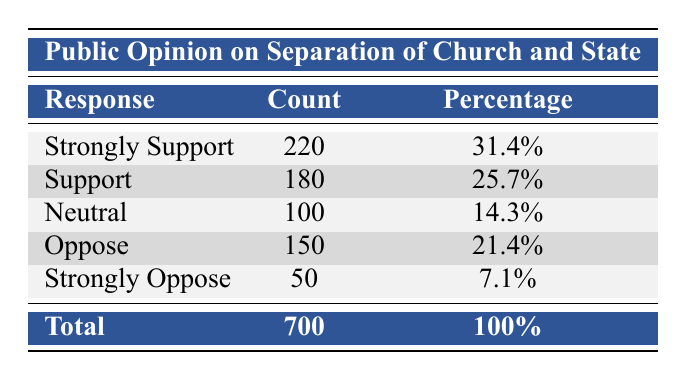What is the percentage of respondents who support the separation of church and state? To find the percentage of those who support, we add the counts for "Support" and "Strongly Support". We get 220 (Strongly Support) + 180 (Support) = 400. To find the percentage, we divide by the total count of 700: (400/700) * 100 = approximately 57.1%.
Answer: 57.1% How many respondents indicated they were neutral on the issue? The table provides the count for the "Neutral" response, which is directly stated in the table as 100.
Answer: 100 What is the combined count of respondents who oppose or strongly oppose the separation of church and state? We add the counts from the "Oppose" and "Strongly Oppose" categories: 150 (Oppose) + 50 (Strongly Oppose) = 200.
Answer: 200 Is it true that more people support than oppose the separation of church and state? To determine this, we compare the counts for "Support" and "Oppose". There are 180 (Support) and 150 (Oppose), so since 180 is greater than 150, the statement is true.
Answer: Yes What percentage of respondents were neutral or opposed to the separation of church and state? We need to find the total count for "Neutral", "Oppose", and "Strongly Oppose": 100 (Neutral) + 150 (Oppose) + 50 (Strongly Oppose) = 300. Then, we calculate the percentage: (300/700) * 100 = approximately 42.9%.
Answer: 42.9% What is the difference in count between those who strongly support and those who strongly oppose? We find the count for "Strongly Support", which is 220, and the count for "Strongly Oppose", which is 50. The difference is 220 - 50 = 170.
Answer: 170 What is the total number of respondents who expressed any kind of support (strongly support or support)? Add the counts of "Strongly Support" and "Support": 220 + 180 = 400.
Answer: 400 Is there a higher percentage of respondents who are neutral compared to those who strongly oppose? The percentage of "Neutral" is 14.3% and for "Strongly Oppose" it is 7.1%. Since 14.3% is greater than 7.1%, the statement is true.
Answer: Yes What is the average percentage of respondents who either support or oppose the separation of church and state? First, we find the total count of supporters (400) and opposers (200). Then, we add the percentages: 31.4% (Strongly Support) + 25.7% (Support) + 21.4% (Oppose) + 7.1% (Strongly Oppose) = 85.6%. Next, we divide by the total number of categories: 85.6/4 = 21.4%.
Answer: 21.4% 